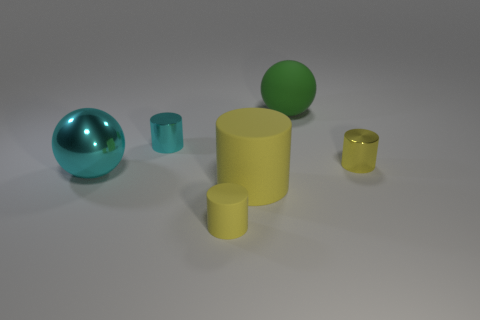There is a cyan metal object that is the same shape as the small yellow rubber thing; what is its size?
Your answer should be very brief. Small. What is the size of the cylinder that is made of the same material as the tiny cyan object?
Provide a short and direct response. Small. Is there a tiny cyan thing?
Offer a very short reply. Yes. There is a big green matte object; is its shape the same as the small yellow thing in front of the yellow shiny thing?
Your answer should be very brief. No. There is a small shiny cylinder that is behind the tiny yellow thing behind the large metal sphere in front of the small cyan thing; what color is it?
Ensure brevity in your answer.  Cyan. There is a cyan ball; are there any big cyan metal balls right of it?
Offer a terse response. No. The other shiny cylinder that is the same color as the large cylinder is what size?
Your response must be concise. Small. Is there a green cylinder that has the same material as the cyan sphere?
Ensure brevity in your answer.  No. What color is the big cylinder?
Make the answer very short. Yellow. There is a small metal object that is on the right side of the green matte ball; is it the same shape as the tiny cyan metallic object?
Your answer should be compact. Yes. 